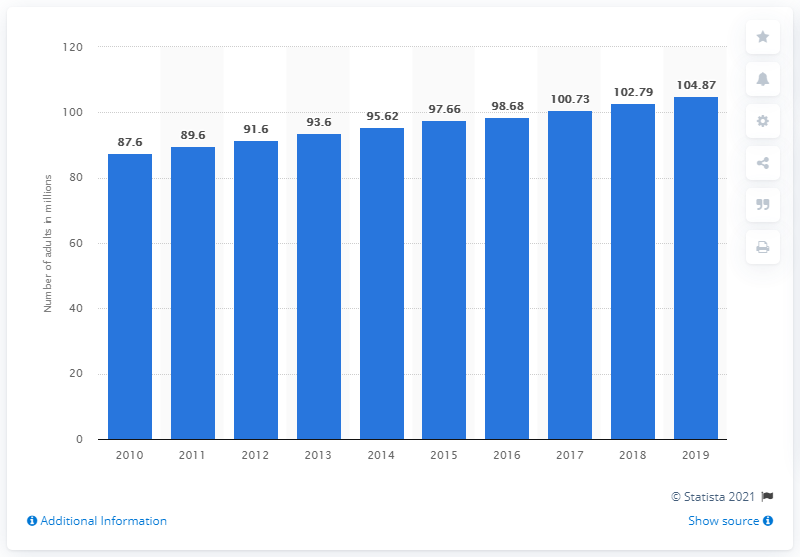Mention a couple of crucial points in this snapshot. In 2019, there were approximately 104.87 million adults in Bangladesh. 